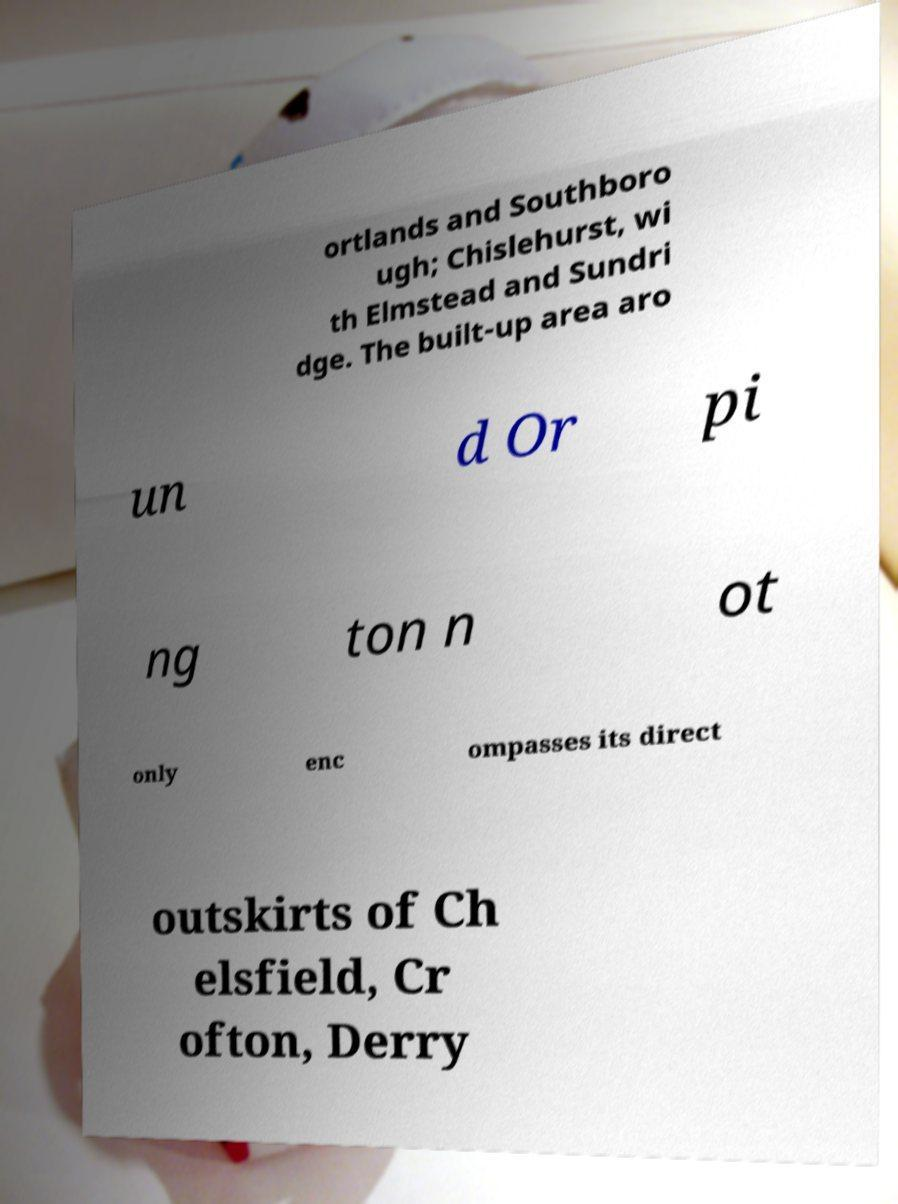What messages or text are displayed in this image? I need them in a readable, typed format. ortlands and Southboro ugh; Chislehurst, wi th Elmstead and Sundri dge. The built-up area aro un d Or pi ng ton n ot only enc ompasses its direct outskirts of Ch elsfield, Cr ofton, Derry 